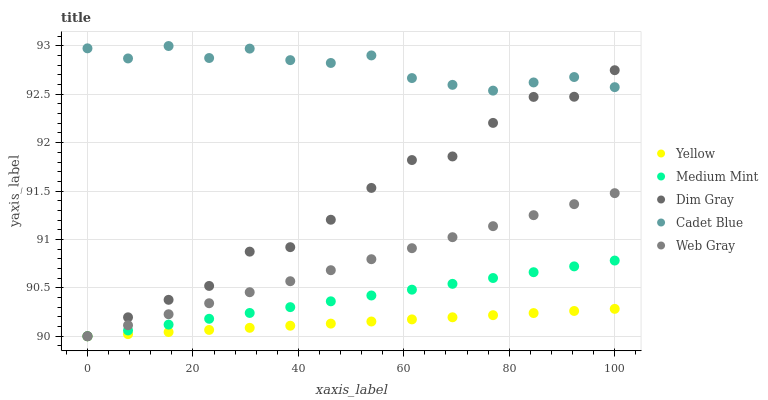Does Yellow have the minimum area under the curve?
Answer yes or no. Yes. Does Cadet Blue have the maximum area under the curve?
Answer yes or no. Yes. Does Dim Gray have the minimum area under the curve?
Answer yes or no. No. Does Dim Gray have the maximum area under the curve?
Answer yes or no. No. Is Web Gray the smoothest?
Answer yes or no. Yes. Is Dim Gray the roughest?
Answer yes or no. Yes. Is Cadet Blue the smoothest?
Answer yes or no. No. Is Cadet Blue the roughest?
Answer yes or no. No. Does Medium Mint have the lowest value?
Answer yes or no. Yes. Does Cadet Blue have the lowest value?
Answer yes or no. No. Does Cadet Blue have the highest value?
Answer yes or no. Yes. Does Dim Gray have the highest value?
Answer yes or no. No. Is Yellow less than Cadet Blue?
Answer yes or no. Yes. Is Cadet Blue greater than Yellow?
Answer yes or no. Yes. Does Medium Mint intersect Web Gray?
Answer yes or no. Yes. Is Medium Mint less than Web Gray?
Answer yes or no. No. Is Medium Mint greater than Web Gray?
Answer yes or no. No. Does Yellow intersect Cadet Blue?
Answer yes or no. No. 